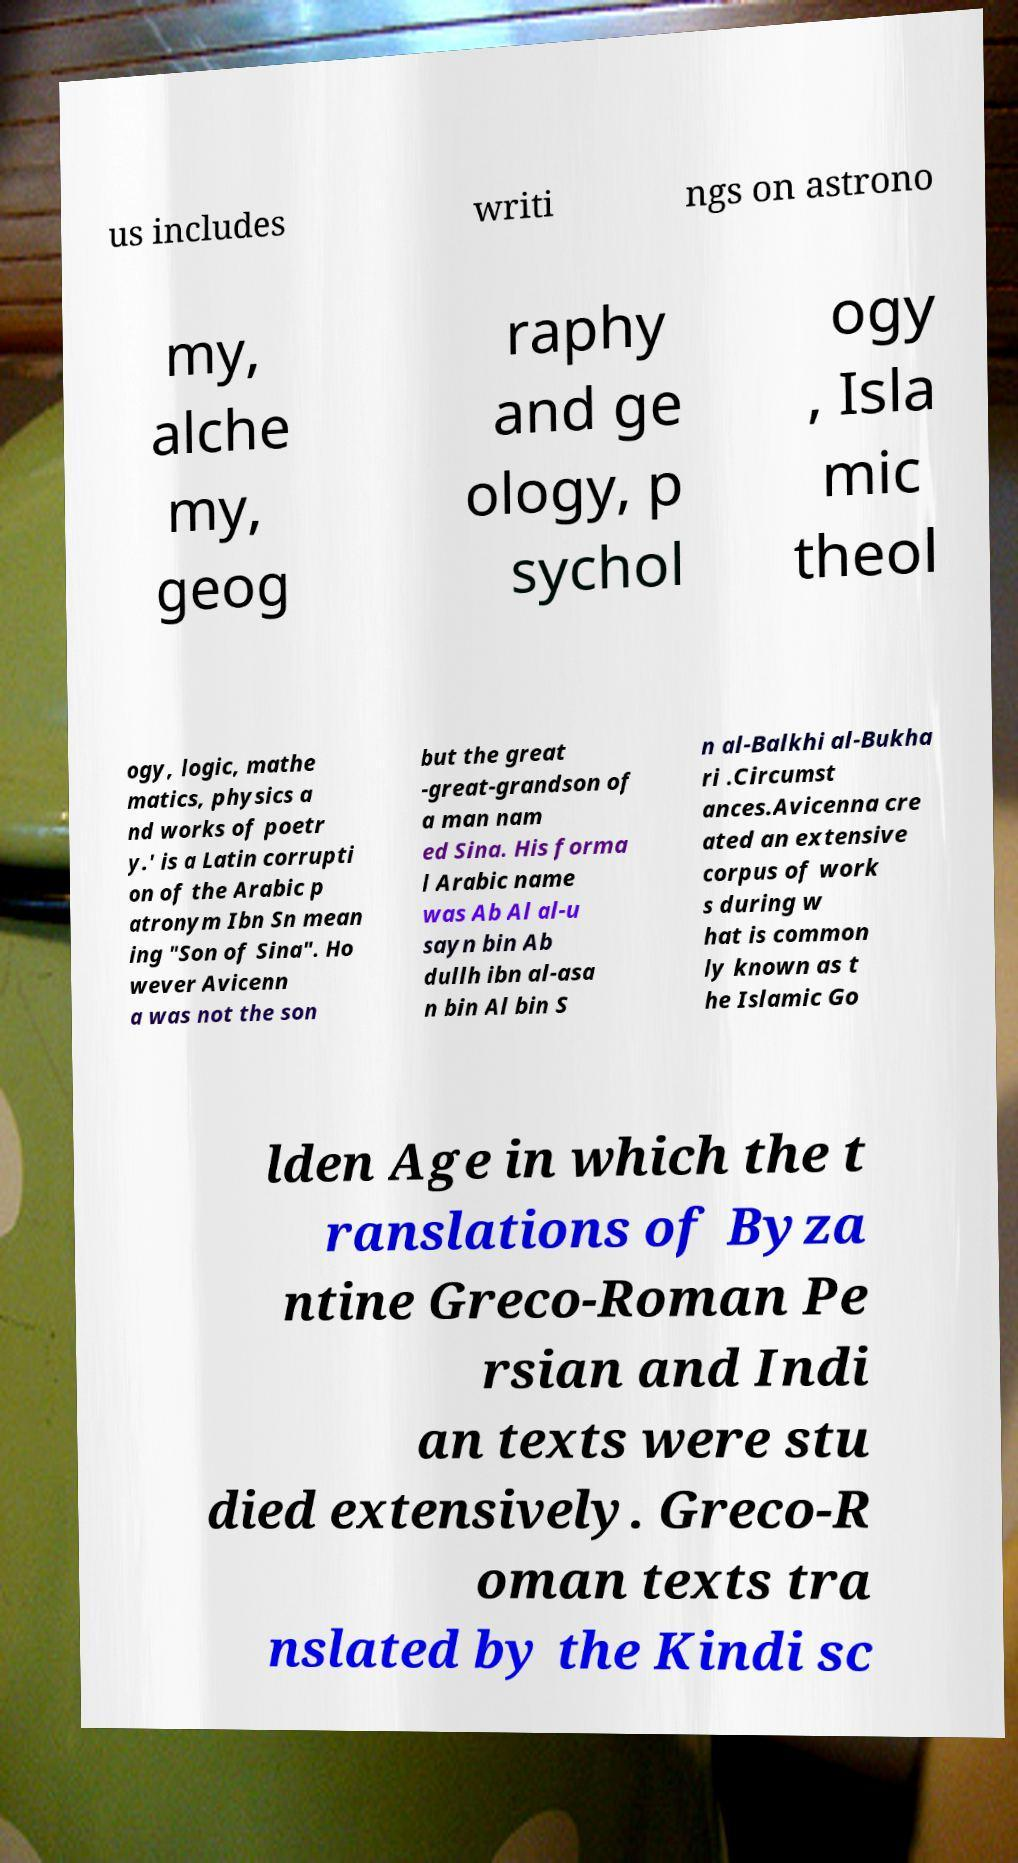Please identify and transcribe the text found in this image. us includes writi ngs on astrono my, alche my, geog raphy and ge ology, p sychol ogy , Isla mic theol ogy, logic, mathe matics, physics a nd works of poetr y.' is a Latin corrupti on of the Arabic p atronym Ibn Sn mean ing "Son of Sina". Ho wever Avicenn a was not the son but the great -great-grandson of a man nam ed Sina. His forma l Arabic name was Ab Al al-u sayn bin Ab dullh ibn al-asa n bin Al bin S n al-Balkhi al-Bukha ri .Circumst ances.Avicenna cre ated an extensive corpus of work s during w hat is common ly known as t he Islamic Go lden Age in which the t ranslations of Byza ntine Greco-Roman Pe rsian and Indi an texts were stu died extensively. Greco-R oman texts tra nslated by the Kindi sc 